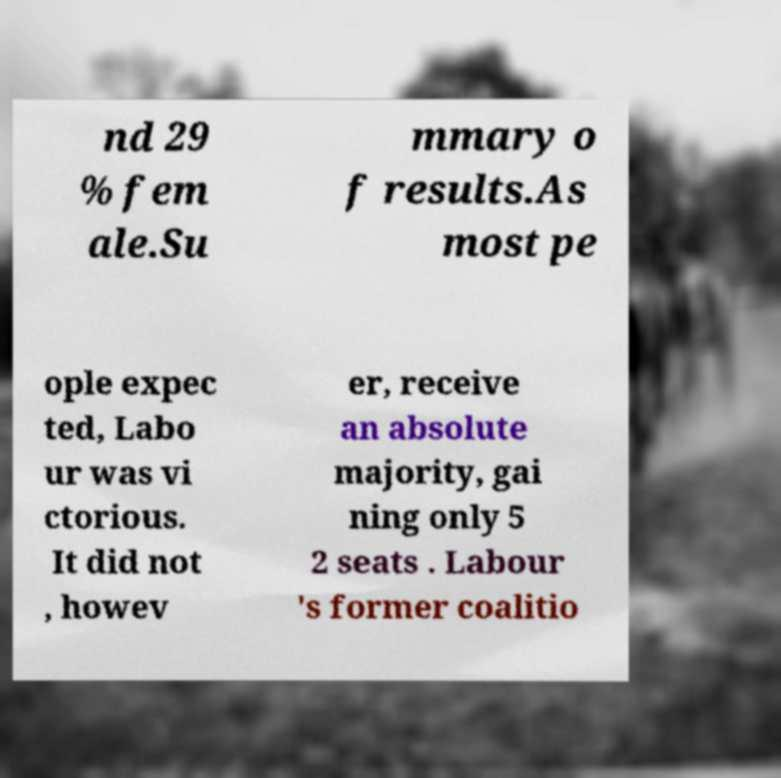For documentation purposes, I need the text within this image transcribed. Could you provide that? nd 29 % fem ale.Su mmary o f results.As most pe ople expec ted, Labo ur was vi ctorious. It did not , howev er, receive an absolute majority, gai ning only 5 2 seats . Labour 's former coalitio 